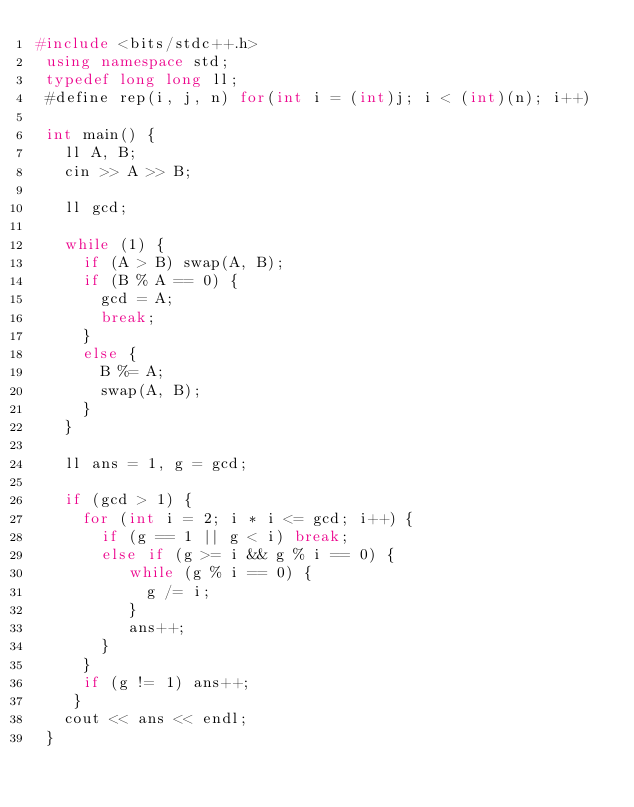Convert code to text. <code><loc_0><loc_0><loc_500><loc_500><_C++_>#include <bits/stdc++.h>
 using namespace std;
 typedef long long ll;
 #define rep(i, j, n) for(int i = (int)j; i < (int)(n); i++)

 int main() {
   ll A, B;
   cin >> A >> B;

   ll gcd;

   while (1) {
     if (A > B) swap(A, B);
     if (B % A == 0) {
       gcd = A;
       break;
     }
     else {
       B %= A;
       swap(A, B);
     }
   }

   ll ans = 1, g = gcd;

   if (gcd > 1) {
     for (int i = 2; i * i <= gcd; i++) {
       if (g == 1 || g < i) break;
       else if (g >= i && g % i == 0) {
          while (g % i == 0) {
            g /= i;
          }
          ans++;
       }
     }
     if (g != 1) ans++;
    }
   cout << ans << endl;
 }
</code> 